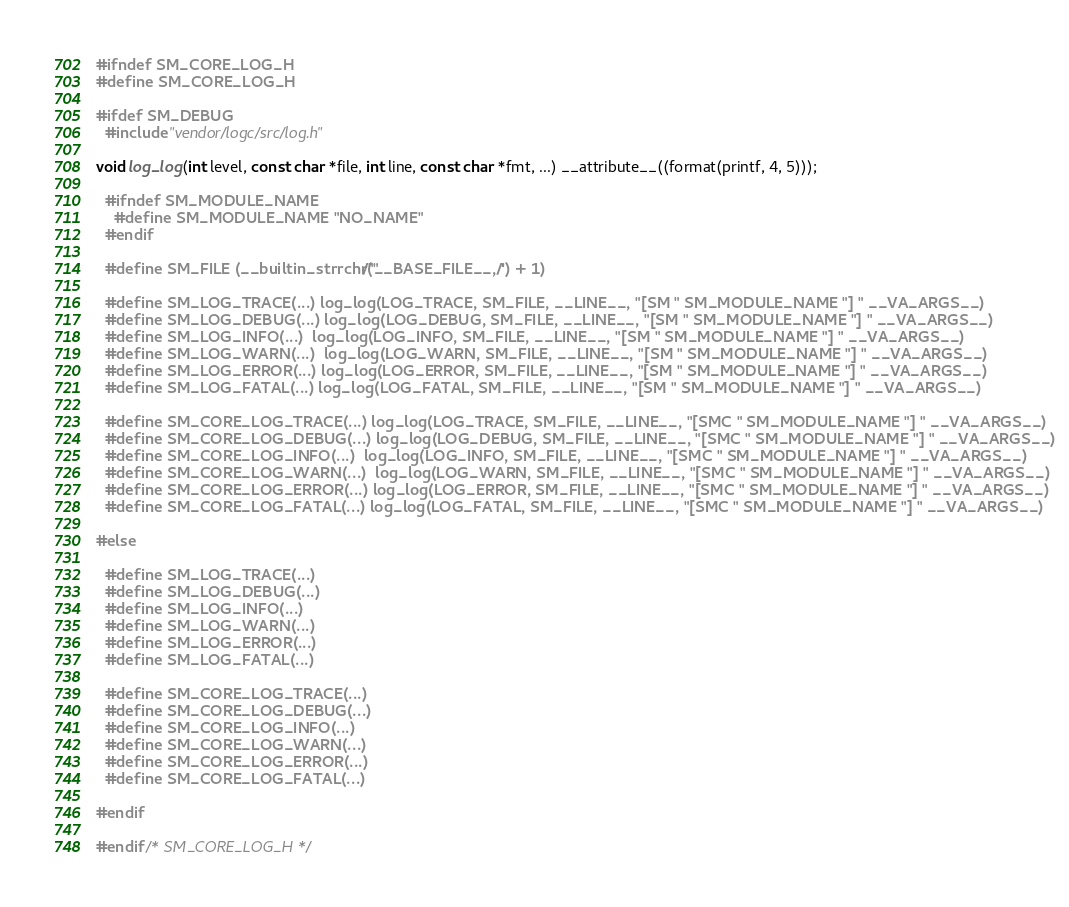Convert code to text. <code><loc_0><loc_0><loc_500><loc_500><_C_>#ifndef SM_CORE_LOG_H
#define SM_CORE_LOG_H

#ifdef SM_DEBUG
  #include "vendor/logc/src/log.h"

void log_log(int level, const char *file, int line, const char *fmt, ...) __attribute__((format(printf, 4, 5)));

  #ifndef SM_MODULE_NAME
    #define SM_MODULE_NAME "NO_NAME"
  #endif

  #define SM_FILE (__builtin_strrchr("/"__BASE_FILE__, '/') + 1)

  #define SM_LOG_TRACE(...) log_log(LOG_TRACE, SM_FILE, __LINE__, "[SM " SM_MODULE_NAME "] " __VA_ARGS__)
  #define SM_LOG_DEBUG(...) log_log(LOG_DEBUG, SM_FILE, __LINE__, "[SM " SM_MODULE_NAME "] " __VA_ARGS__)
  #define SM_LOG_INFO(...)  log_log(LOG_INFO, SM_FILE, __LINE__, "[SM " SM_MODULE_NAME "] " __VA_ARGS__)
  #define SM_LOG_WARN(...)  log_log(LOG_WARN, SM_FILE, __LINE__, "[SM " SM_MODULE_NAME "] " __VA_ARGS__)
  #define SM_LOG_ERROR(...) log_log(LOG_ERROR, SM_FILE, __LINE__, "[SM " SM_MODULE_NAME "] " __VA_ARGS__)
  #define SM_LOG_FATAL(...) log_log(LOG_FATAL, SM_FILE, __LINE__, "[SM " SM_MODULE_NAME "] " __VA_ARGS__)

  #define SM_CORE_LOG_TRACE(...) log_log(LOG_TRACE, SM_FILE, __LINE__, "[SMC " SM_MODULE_NAME "] " __VA_ARGS__)
  #define SM_CORE_LOG_DEBUG(...) log_log(LOG_DEBUG, SM_FILE, __LINE__, "[SMC " SM_MODULE_NAME "] " __VA_ARGS__)
  #define SM_CORE_LOG_INFO(...)  log_log(LOG_INFO, SM_FILE, __LINE__, "[SMC " SM_MODULE_NAME "] " __VA_ARGS__)
  #define SM_CORE_LOG_WARN(...)  log_log(LOG_WARN, SM_FILE, __LINE__, "[SMC " SM_MODULE_NAME "] " __VA_ARGS__)
  #define SM_CORE_LOG_ERROR(...) log_log(LOG_ERROR, SM_FILE, __LINE__, "[SMC " SM_MODULE_NAME "] " __VA_ARGS__)
  #define SM_CORE_LOG_FATAL(...) log_log(LOG_FATAL, SM_FILE, __LINE__, "[SMC " SM_MODULE_NAME "] " __VA_ARGS__)

#else

  #define SM_LOG_TRACE(...)
  #define SM_LOG_DEBUG(...)
  #define SM_LOG_INFO(...)
  #define SM_LOG_WARN(...)
  #define SM_LOG_ERROR(...)
  #define SM_LOG_FATAL(...)

  #define SM_CORE_LOG_TRACE(...)
  #define SM_CORE_LOG_DEBUG(...)
  #define SM_CORE_LOG_INFO(...)
  #define SM_CORE_LOG_WARN(...)
  #define SM_CORE_LOG_ERROR(...)
  #define SM_CORE_LOG_FATAL(...)

#endif

#endif /* SM_CORE_LOG_H */
</code> 